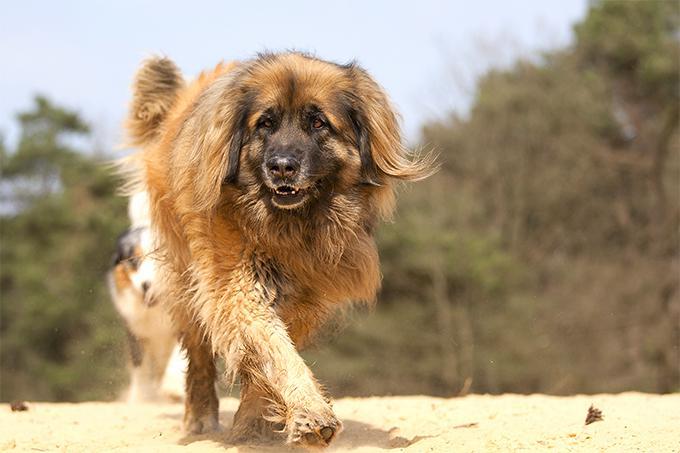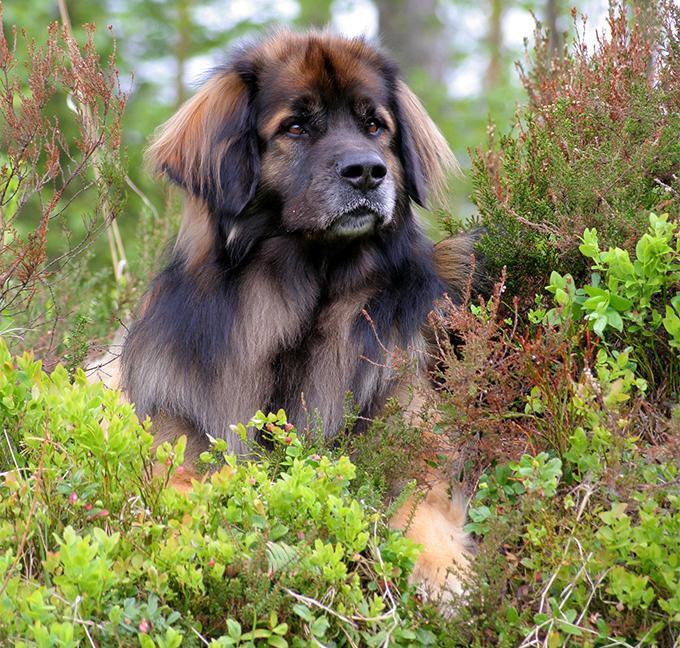The first image is the image on the left, the second image is the image on the right. Considering the images on both sides, is "At least one dog is laying down." valid? Answer yes or no. Yes. 